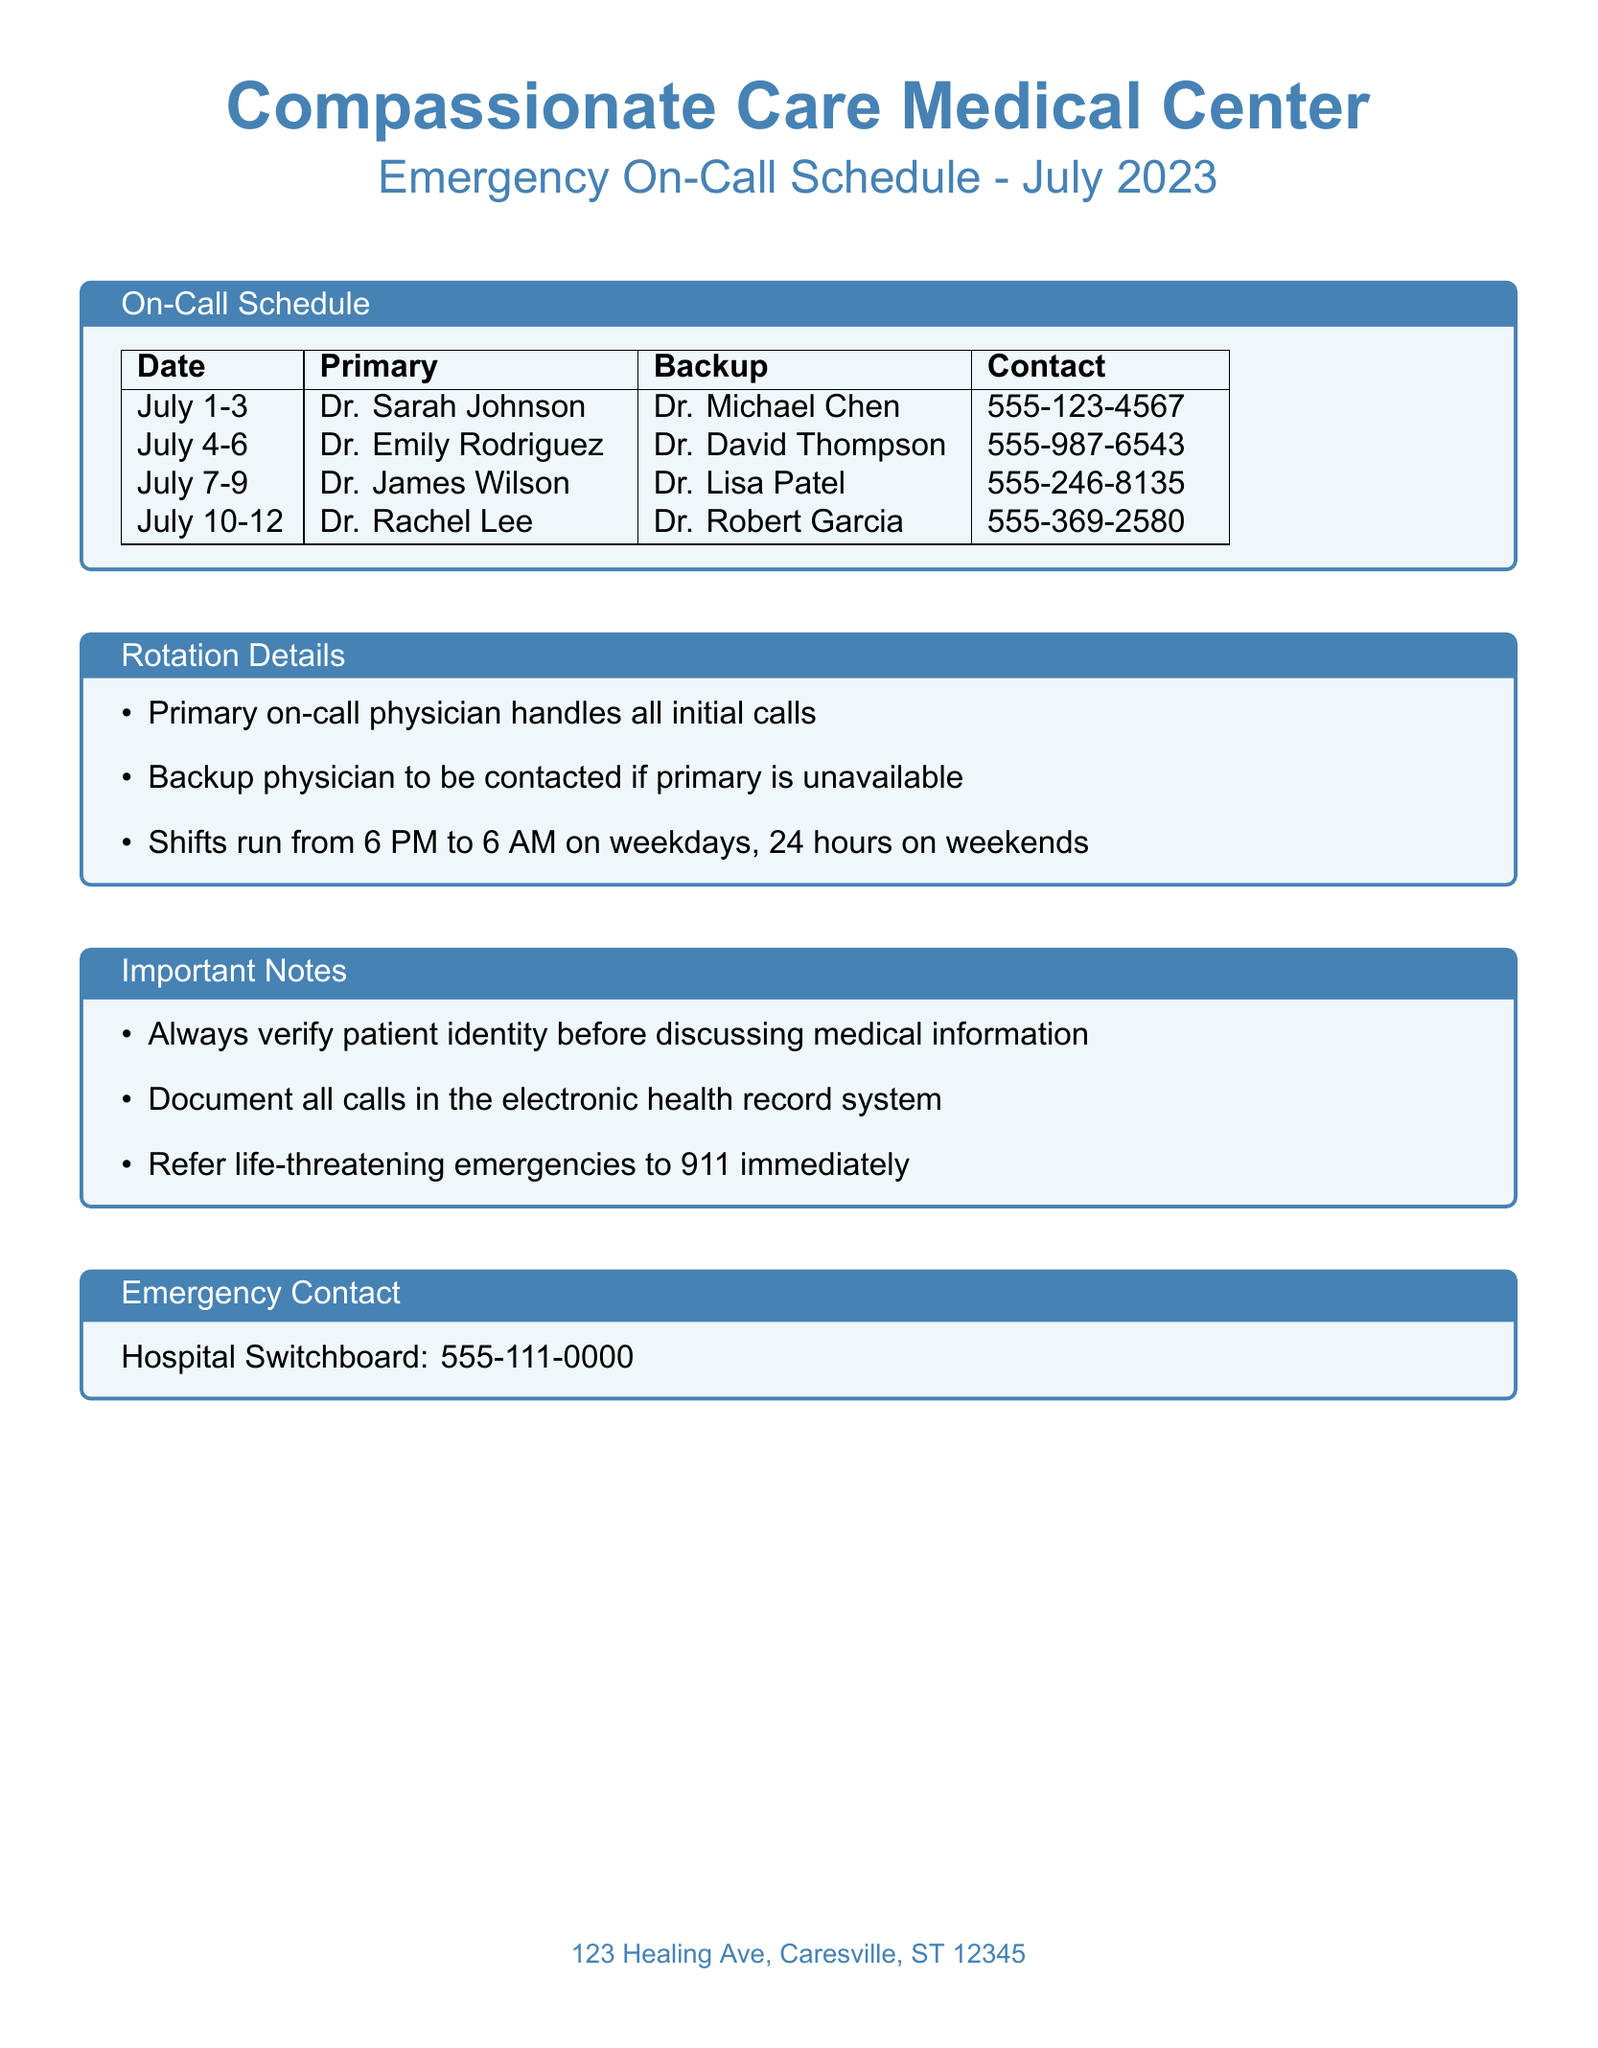What are the primary on-call dates for July? The primary on-call dates are listed in the schedule, specifically from July 1-3, July 4-6, July 7-9, and July 10-12.
Answer: July 1-3, July 4-6, July 7-9, July 10-12 Who is the backup for July 4-6? The backup physician for July 4-6 is mentioned in the schedule.
Answer: Dr. David Thompson What is the contact number for Dr. Rachel Lee? The contact number is provided in the on-call schedule table for the corresponding dates.
Answer: 555-369-2580 How long do shifts run on weekdays? The document specifies that shifts on weekdays run from 6 PM to 6 AM.
Answer: 6 PM to 6 AM Who should be contacted for life-threatening emergencies? The document explicitly states that life-threatening emergencies should be referred to 911.
Answer: 911 What is the role of the primary on-call physician? The document outlines the primary physician's responsibility in handling initial calls.
Answer: Handle all initial calls How many hours do weekend shifts cover? The document indicates that weekend shifts cover a specific duration.
Answer: 24 hours What is the address of the Compassionate Care Medical Center? The address of the medical center is included at the bottom of the document.
Answer: 123 Healing Ave, Caresville, ST 12345 